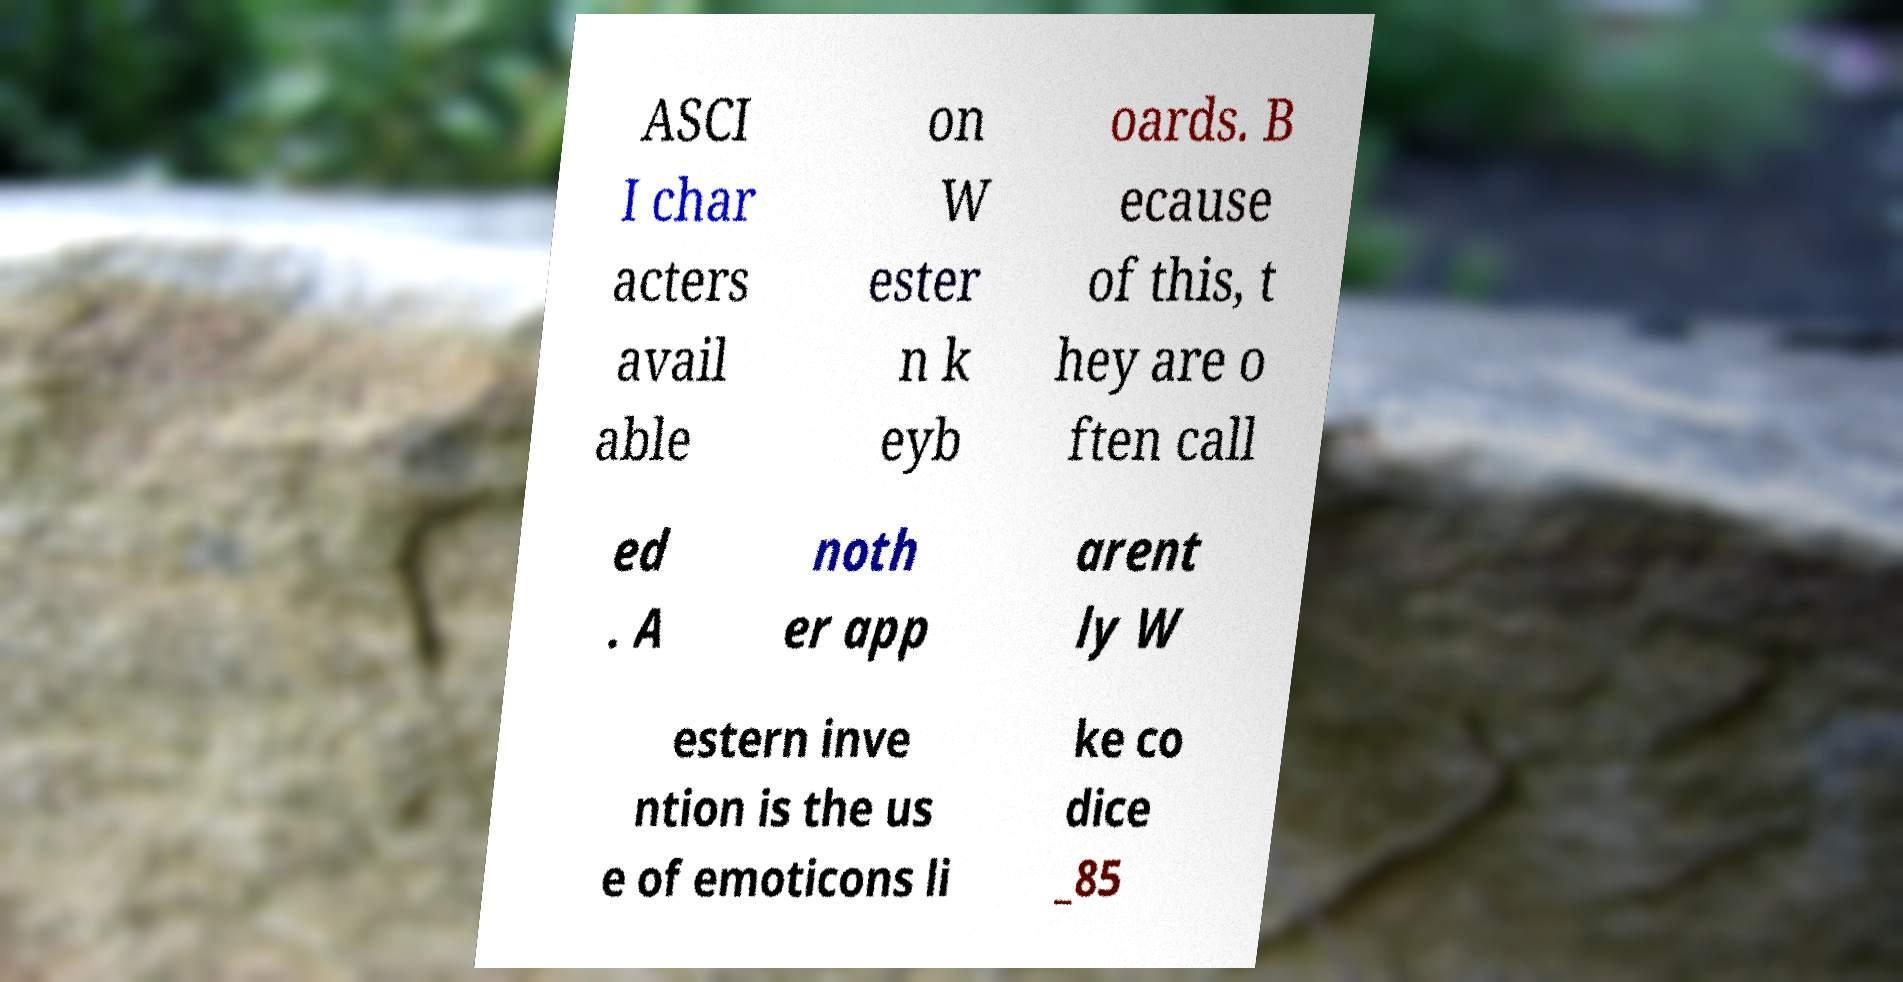What messages or text are displayed in this image? I need them in a readable, typed format. ASCI I char acters avail able on W ester n k eyb oards. B ecause of this, t hey are o ften call ed . A noth er app arent ly W estern inve ntion is the us e of emoticons li ke co dice _85 